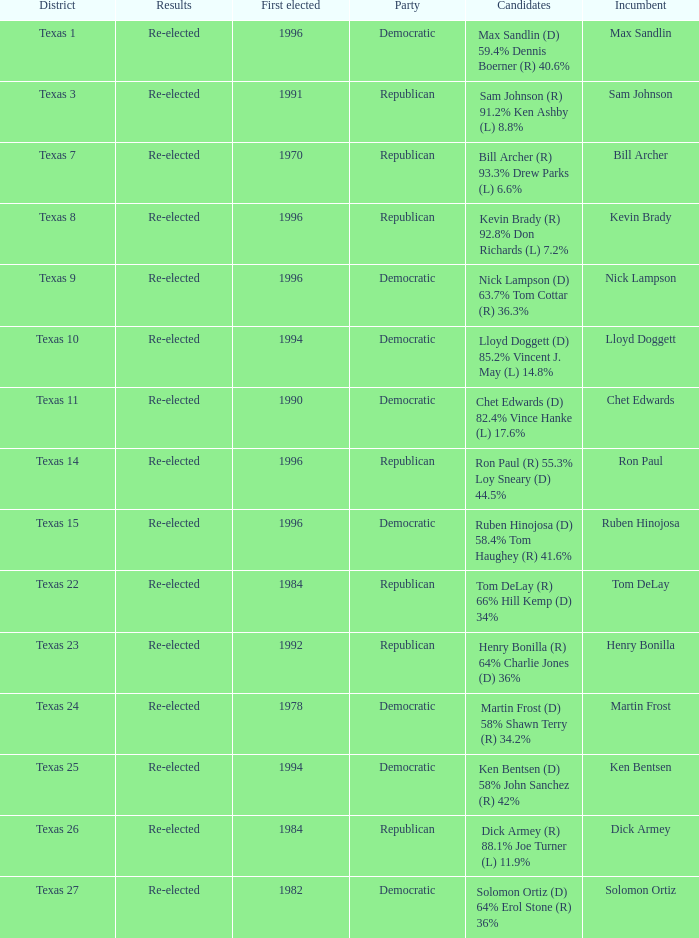How many times did incumbent ruben hinojosa get elected? 1.0. 